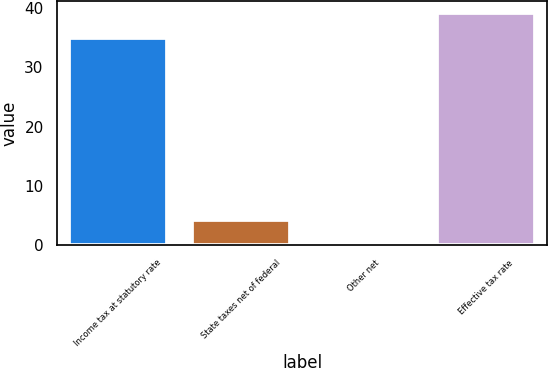Convert chart. <chart><loc_0><loc_0><loc_500><loc_500><bar_chart><fcel>Income tax at statutory rate<fcel>State taxes net of federal<fcel>Other net<fcel>Effective tax rate<nl><fcel>35<fcel>4.28<fcel>0.4<fcel>39.2<nl></chart> 